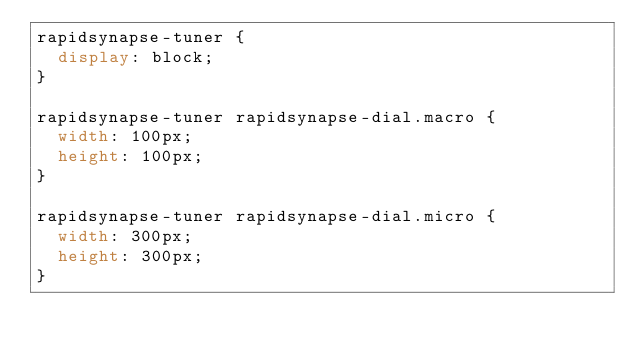Convert code to text. <code><loc_0><loc_0><loc_500><loc_500><_CSS_>rapidsynapse-tuner {
  display: block;
}

rapidsynapse-tuner rapidsynapse-dial.macro {
  width: 100px;
  height: 100px;
}

rapidsynapse-tuner rapidsynapse-dial.micro {
  width: 300px;
  height: 300px;
}

</code> 